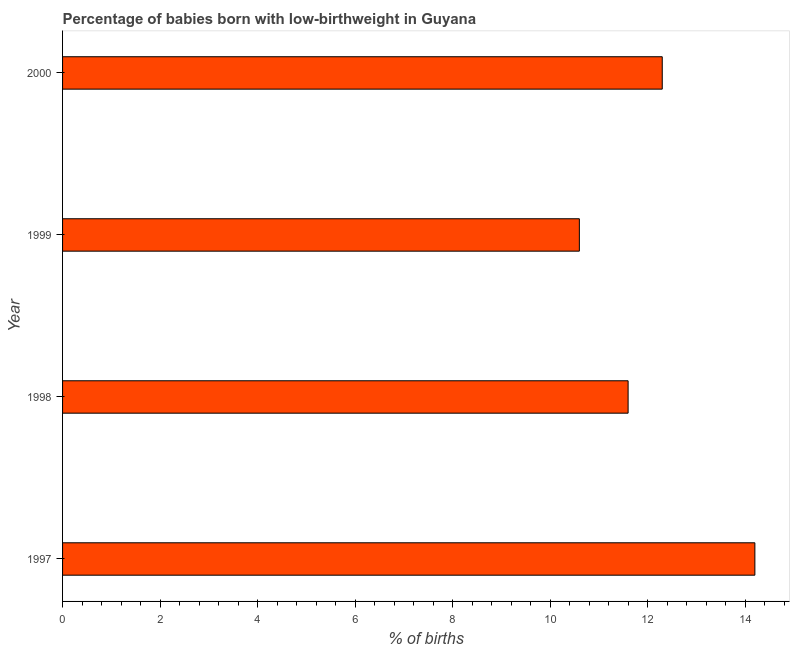Does the graph contain any zero values?
Your response must be concise. No. What is the title of the graph?
Make the answer very short. Percentage of babies born with low-birthweight in Guyana. What is the label or title of the X-axis?
Your answer should be compact. % of births. What is the percentage of babies who were born with low-birthweight in 1997?
Your response must be concise. 14.2. Across all years, what is the minimum percentage of babies who were born with low-birthweight?
Your response must be concise. 10.6. In which year was the percentage of babies who were born with low-birthweight minimum?
Give a very brief answer. 1999. What is the sum of the percentage of babies who were born with low-birthweight?
Provide a short and direct response. 48.7. What is the difference between the percentage of babies who were born with low-birthweight in 1998 and 2000?
Keep it short and to the point. -0.7. What is the average percentage of babies who were born with low-birthweight per year?
Provide a short and direct response. 12.18. What is the median percentage of babies who were born with low-birthweight?
Keep it short and to the point. 11.95. In how many years, is the percentage of babies who were born with low-birthweight greater than 8.4 %?
Your answer should be very brief. 4. Do a majority of the years between 1999 and 1998 (inclusive) have percentage of babies who were born with low-birthweight greater than 9.6 %?
Ensure brevity in your answer.  No. What is the ratio of the percentage of babies who were born with low-birthweight in 1997 to that in 1999?
Offer a very short reply. 1.34. Is the sum of the percentage of babies who were born with low-birthweight in 1998 and 1999 greater than the maximum percentage of babies who were born with low-birthweight across all years?
Provide a short and direct response. Yes. Are all the bars in the graph horizontal?
Provide a short and direct response. Yes. How many years are there in the graph?
Provide a short and direct response. 4. What is the difference between two consecutive major ticks on the X-axis?
Offer a very short reply. 2. What is the % of births of 1997?
Ensure brevity in your answer.  14.2. What is the % of births in 1999?
Ensure brevity in your answer.  10.6. What is the difference between the % of births in 1997 and 1998?
Your answer should be compact. 2.6. What is the difference between the % of births in 1997 and 1999?
Your answer should be compact. 3.6. What is the difference between the % of births in 1998 and 2000?
Give a very brief answer. -0.7. What is the difference between the % of births in 1999 and 2000?
Offer a very short reply. -1.7. What is the ratio of the % of births in 1997 to that in 1998?
Ensure brevity in your answer.  1.22. What is the ratio of the % of births in 1997 to that in 1999?
Provide a succinct answer. 1.34. What is the ratio of the % of births in 1997 to that in 2000?
Provide a short and direct response. 1.15. What is the ratio of the % of births in 1998 to that in 1999?
Make the answer very short. 1.09. What is the ratio of the % of births in 1998 to that in 2000?
Ensure brevity in your answer.  0.94. What is the ratio of the % of births in 1999 to that in 2000?
Your answer should be very brief. 0.86. 